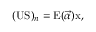Convert formula to latex. <formula><loc_0><loc_0><loc_500><loc_500>( U S ) _ { n } = E ( \vec { \alpha } ) x ,</formula> 